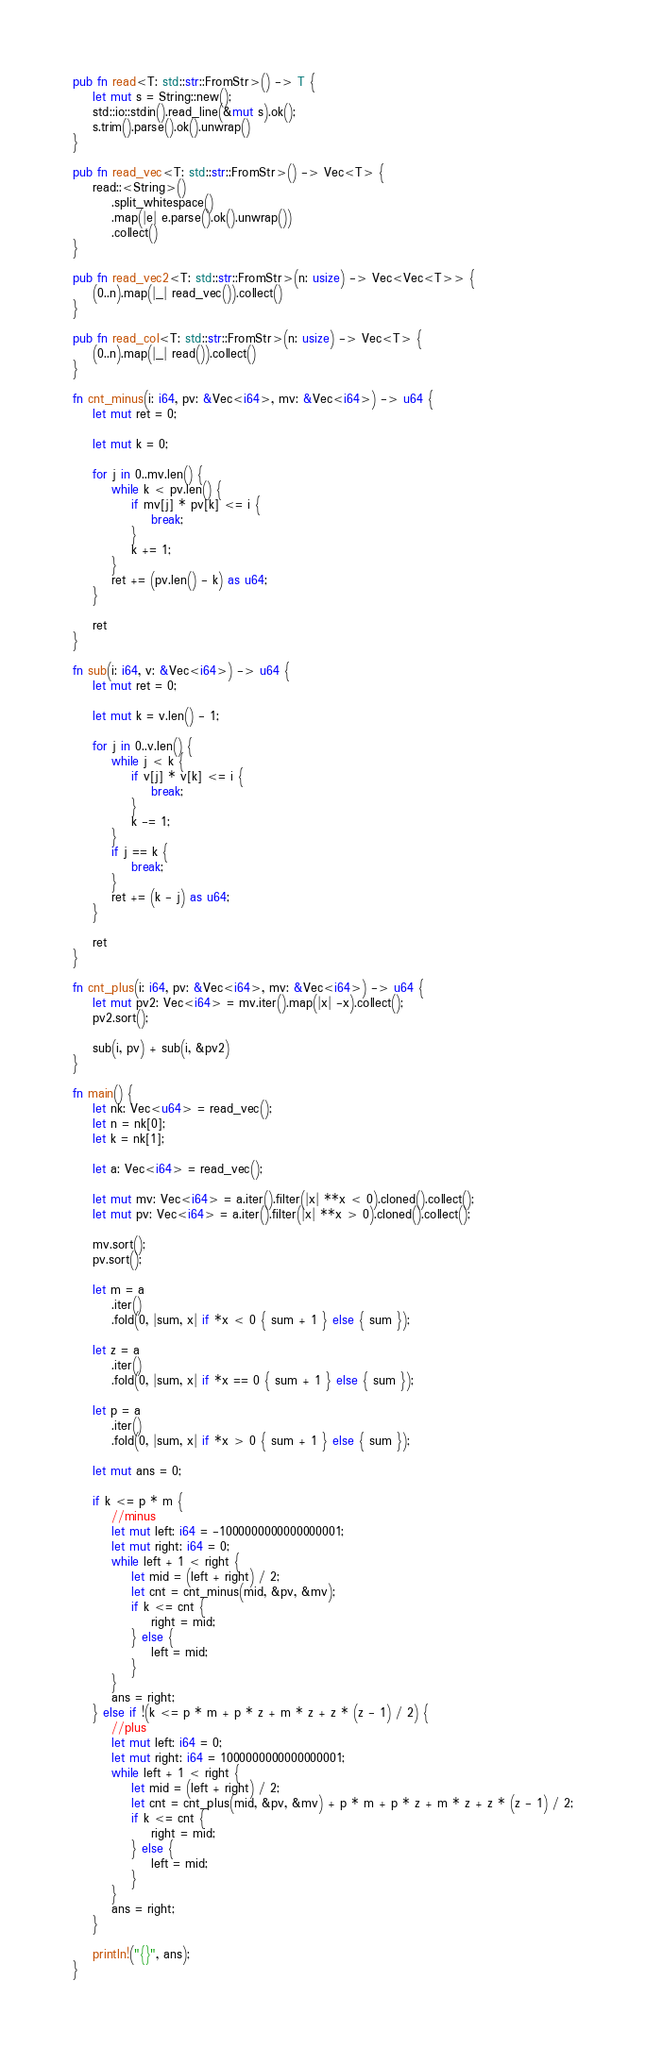<code> <loc_0><loc_0><loc_500><loc_500><_Rust_>pub fn read<T: std::str::FromStr>() -> T {
    let mut s = String::new();
    std::io::stdin().read_line(&mut s).ok();
    s.trim().parse().ok().unwrap()
}

pub fn read_vec<T: std::str::FromStr>() -> Vec<T> {
    read::<String>()
        .split_whitespace()
        .map(|e| e.parse().ok().unwrap())
        .collect()
}

pub fn read_vec2<T: std::str::FromStr>(n: usize) -> Vec<Vec<T>> {
    (0..n).map(|_| read_vec()).collect()
}

pub fn read_col<T: std::str::FromStr>(n: usize) -> Vec<T> {
    (0..n).map(|_| read()).collect()
}

fn cnt_minus(i: i64, pv: &Vec<i64>, mv: &Vec<i64>) -> u64 {
    let mut ret = 0;

    let mut k = 0;

    for j in 0..mv.len() {
        while k < pv.len() {
            if mv[j] * pv[k] <= i {
                break;
            }
            k += 1;
        }
        ret += (pv.len() - k) as u64;
    }

    ret
}

fn sub(i: i64, v: &Vec<i64>) -> u64 {
    let mut ret = 0;

    let mut k = v.len() - 1;

    for j in 0..v.len() {
        while j < k {
            if v[j] * v[k] <= i {
                break;
            }
            k -= 1;
        }
        if j == k {
            break;
        }
        ret += (k - j) as u64;
    }

    ret
}

fn cnt_plus(i: i64, pv: &Vec<i64>, mv: &Vec<i64>) -> u64 {
    let mut pv2: Vec<i64> = mv.iter().map(|x| -x).collect();
    pv2.sort();

    sub(i, pv) + sub(i, &pv2)
}

fn main() {
    let nk: Vec<u64> = read_vec();
    let n = nk[0];
    let k = nk[1];

    let a: Vec<i64> = read_vec();

    let mut mv: Vec<i64> = a.iter().filter(|x| **x < 0).cloned().collect();
    let mut pv: Vec<i64> = a.iter().filter(|x| **x > 0).cloned().collect();

    mv.sort();
    pv.sort();

    let m = a
        .iter()
        .fold(0, |sum, x| if *x < 0 { sum + 1 } else { sum });

    let z = a
        .iter()
        .fold(0, |sum, x| if *x == 0 { sum + 1 } else { sum });

    let p = a
        .iter()
        .fold(0, |sum, x| if *x > 0 { sum + 1 } else { sum });

    let mut ans = 0;

    if k <= p * m {
        //minus
        let mut left: i64 = -1000000000000000001;
        let mut right: i64 = 0;
        while left + 1 < right {
            let mid = (left + right) / 2;
            let cnt = cnt_minus(mid, &pv, &mv);
            if k <= cnt {
                right = mid;
            } else {
                left = mid;
            }
        }
        ans = right;
    } else if !(k <= p * m + p * z + m * z + z * (z - 1) / 2) {
        //plus
        let mut left: i64 = 0;
        let mut right: i64 = 1000000000000000001;
        while left + 1 < right {
            let mid = (left + right) / 2;
            let cnt = cnt_plus(mid, &pv, &mv) + p * m + p * z + m * z + z * (z - 1) / 2;
            if k <= cnt {
                right = mid;
            } else {
                left = mid;
            }
        }
        ans = right;
    }

    println!("{}", ans);
}
</code> 